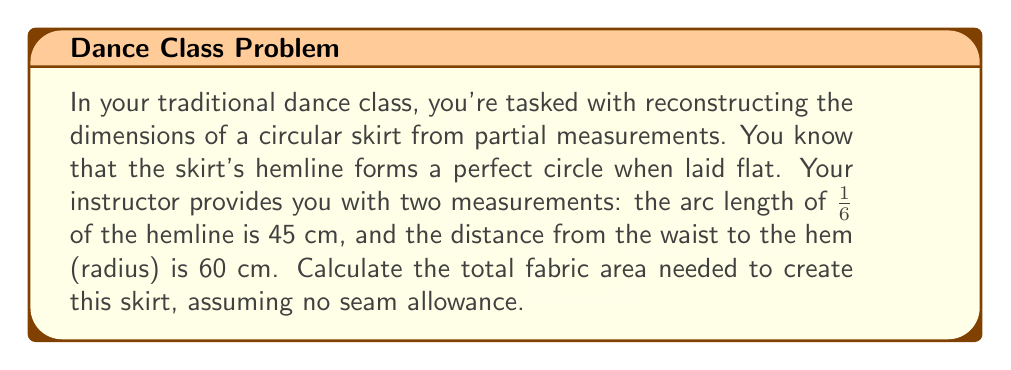Can you answer this question? Let's approach this step-by-step:

1) First, we need to find the circumference of the skirt's hemline.
   We know that 1/6 of the circumference is 45 cm.
   So, the full circumference $C = 45 \times 6 = 270$ cm

2) Now we can find the radius of the hemline circle using the formula:
   $C = 2\pi r$
   $270 = 2\pi r$
   $r = \frac{270}{2\pi} \approx 42.97$ cm

3) The skirt forms a circular sector. To find its area, we need:
   - The radius from waist to hem (given as 60 cm)
   - The radius of the hemline circle (calculated as 42.97 cm)

4) The area of the skirt will be the difference between:
   - The area of the larger circle (waist to hem)
   - The area of the smaller circle (waist circle)

5) Area of larger circle:
   $A_1 = \pi r^2 = \pi \times 60^2 \approx 11309.73$ cm²

6) Area of smaller circle:
   $A_2 = \pi r^2 = \pi \times 42.97^2 \approx 5800.31$ cm²

7) Area of the skirt:
   $A_{skirt} = A_1 - A_2 = 11309.73 - 5800.31 \approx 5509.42$ cm²

Therefore, the total fabric area needed is approximately 5509.42 cm².
Answer: 5509.42 cm² 